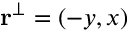Convert formula to latex. <formula><loc_0><loc_0><loc_500><loc_500>r ^ { \perp } = ( - y , x )</formula> 